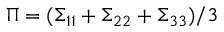<formula> <loc_0><loc_0><loc_500><loc_500>\Pi = ( \Sigma _ { 1 1 } + \Sigma _ { 2 2 } + \Sigma _ { 3 3 } ) / 3</formula> 